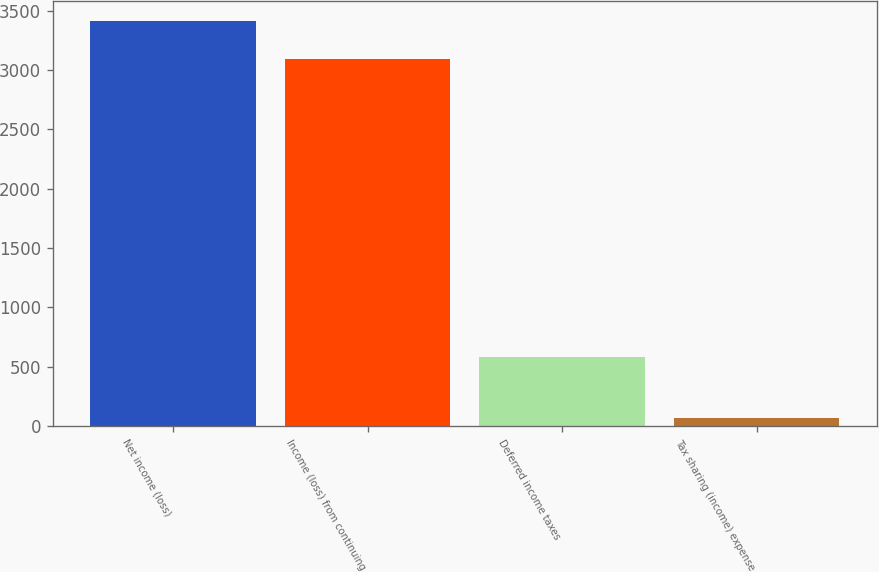Convert chart to OTSL. <chart><loc_0><loc_0><loc_500><loc_500><bar_chart><fcel>Net income (loss)<fcel>Income (loss) from continuing<fcel>Deferred income taxes<fcel>Tax sharing (income) expense<nl><fcel>3412.2<fcel>3094<fcel>583<fcel>68<nl></chart> 